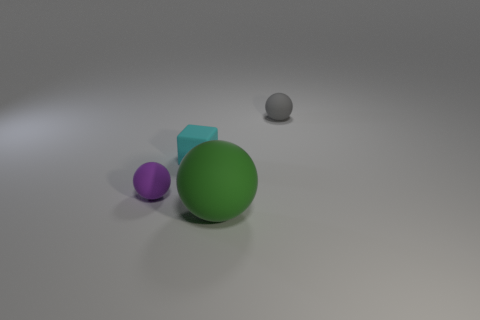Add 2 green spheres. How many objects exist? 6 Subtract all blocks. How many objects are left? 3 Subtract all tiny purple rubber objects. Subtract all small rubber cubes. How many objects are left? 2 Add 3 small gray spheres. How many small gray spheres are left? 4 Add 2 red cylinders. How many red cylinders exist? 2 Subtract 1 purple balls. How many objects are left? 3 